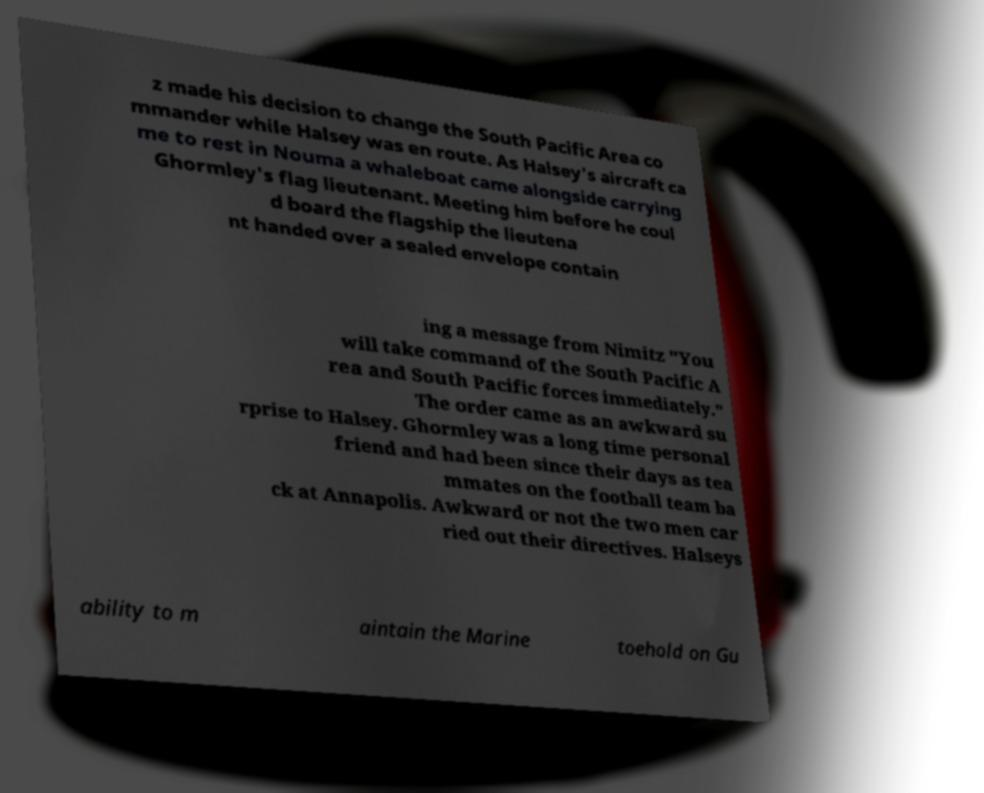Please identify and transcribe the text found in this image. z made his decision to change the South Pacific Area co mmander while Halsey was en route. As Halsey's aircraft ca me to rest in Nouma a whaleboat came alongside carrying Ghormley's flag lieutenant. Meeting him before he coul d board the flagship the lieutena nt handed over a sealed envelope contain ing a message from Nimitz "You will take command of the South Pacific A rea and South Pacific forces immediately." The order came as an awkward su rprise to Halsey. Ghormley was a long time personal friend and had been since their days as tea mmates on the football team ba ck at Annapolis. Awkward or not the two men car ried out their directives. Halseys ability to m aintain the Marine toehold on Gu 